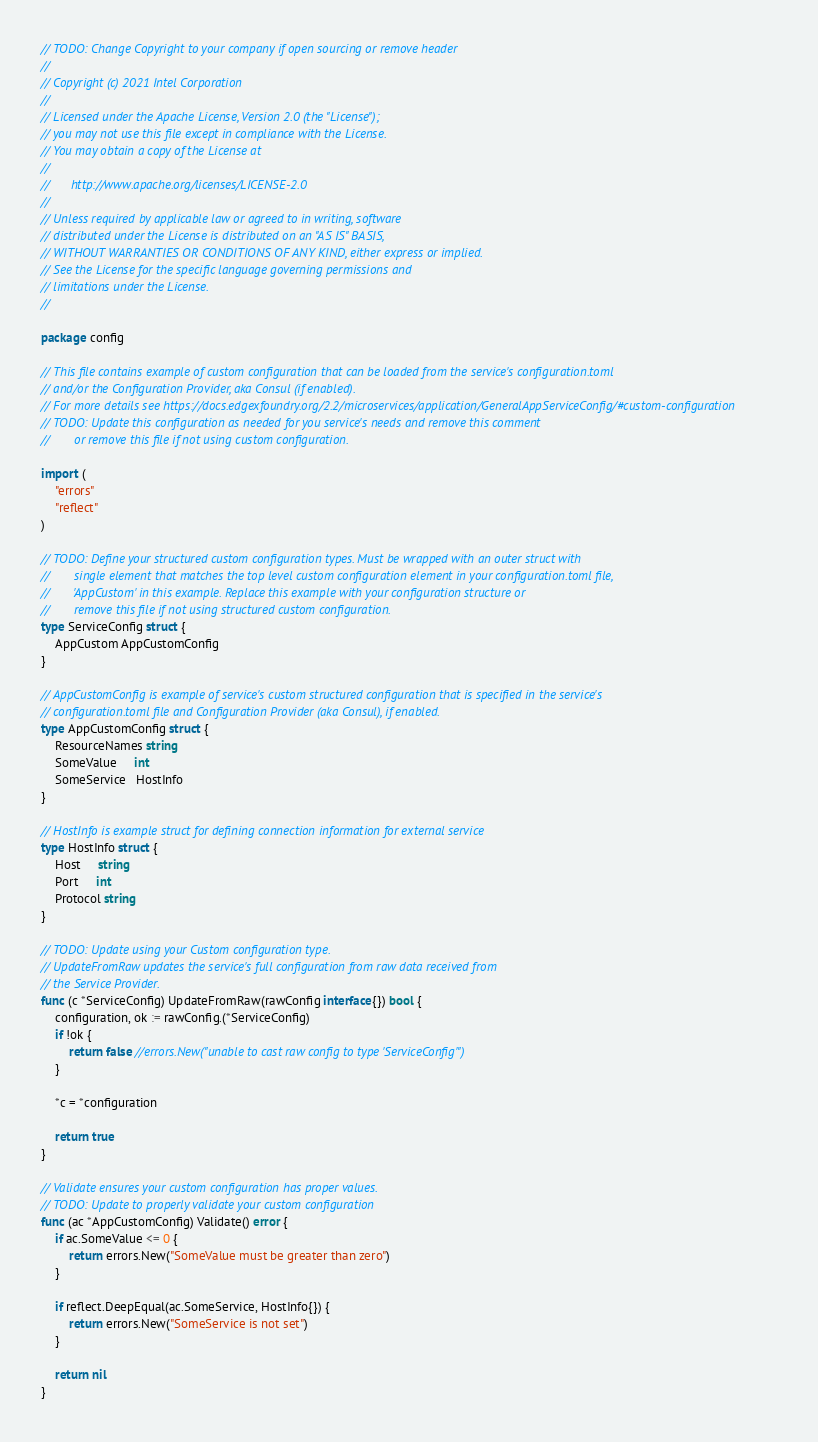<code> <loc_0><loc_0><loc_500><loc_500><_Go_>// TODO: Change Copyright to your company if open sourcing or remove header
//
// Copyright (c) 2021 Intel Corporation
//
// Licensed under the Apache License, Version 2.0 (the "License");
// you may not use this file except in compliance with the License.
// You may obtain a copy of the License at
//
//      http://www.apache.org/licenses/LICENSE-2.0
//
// Unless required by applicable law or agreed to in writing, software
// distributed under the License is distributed on an "AS IS" BASIS,
// WITHOUT WARRANTIES OR CONDITIONS OF ANY KIND, either express or implied.
// See the License for the specific language governing permissions and
// limitations under the License.
//

package config

// This file contains example of custom configuration that can be loaded from the service's configuration.toml
// and/or the Configuration Provider, aka Consul (if enabled).
// For more details see https://docs.edgexfoundry.org/2.2/microservices/application/GeneralAppServiceConfig/#custom-configuration
// TODO: Update this configuration as needed for you service's needs and remove this comment
//       or remove this file if not using custom configuration.

import (
	"errors"
	"reflect"
)

// TODO: Define your structured custom configuration types. Must be wrapped with an outer struct with
//       single element that matches the top level custom configuration element in your configuration.toml file,
//       'AppCustom' in this example. Replace this example with your configuration structure or
//       remove this file if not using structured custom configuration.
type ServiceConfig struct {
	AppCustom AppCustomConfig
}

// AppCustomConfig is example of service's custom structured configuration that is specified in the service's
// configuration.toml file and Configuration Provider (aka Consul), if enabled.
type AppCustomConfig struct {
	ResourceNames string
	SomeValue     int
	SomeService   HostInfo
}

// HostInfo is example struct for defining connection information for external service
type HostInfo struct {
	Host     string
	Port     int
	Protocol string
}

// TODO: Update using your Custom configuration type.
// UpdateFromRaw updates the service's full configuration from raw data received from
// the Service Provider.
func (c *ServiceConfig) UpdateFromRaw(rawConfig interface{}) bool {
	configuration, ok := rawConfig.(*ServiceConfig)
	if !ok {
		return false //errors.New("unable to cast raw config to type 'ServiceConfig'")
	}

	*c = *configuration

	return true
}

// Validate ensures your custom configuration has proper values.
// TODO: Update to properly validate your custom configuration
func (ac *AppCustomConfig) Validate() error {
	if ac.SomeValue <= 0 {
		return errors.New("SomeValue must be greater than zero")
	}

	if reflect.DeepEqual(ac.SomeService, HostInfo{}) {
		return errors.New("SomeService is not set")
	}

	return nil
}
</code> 